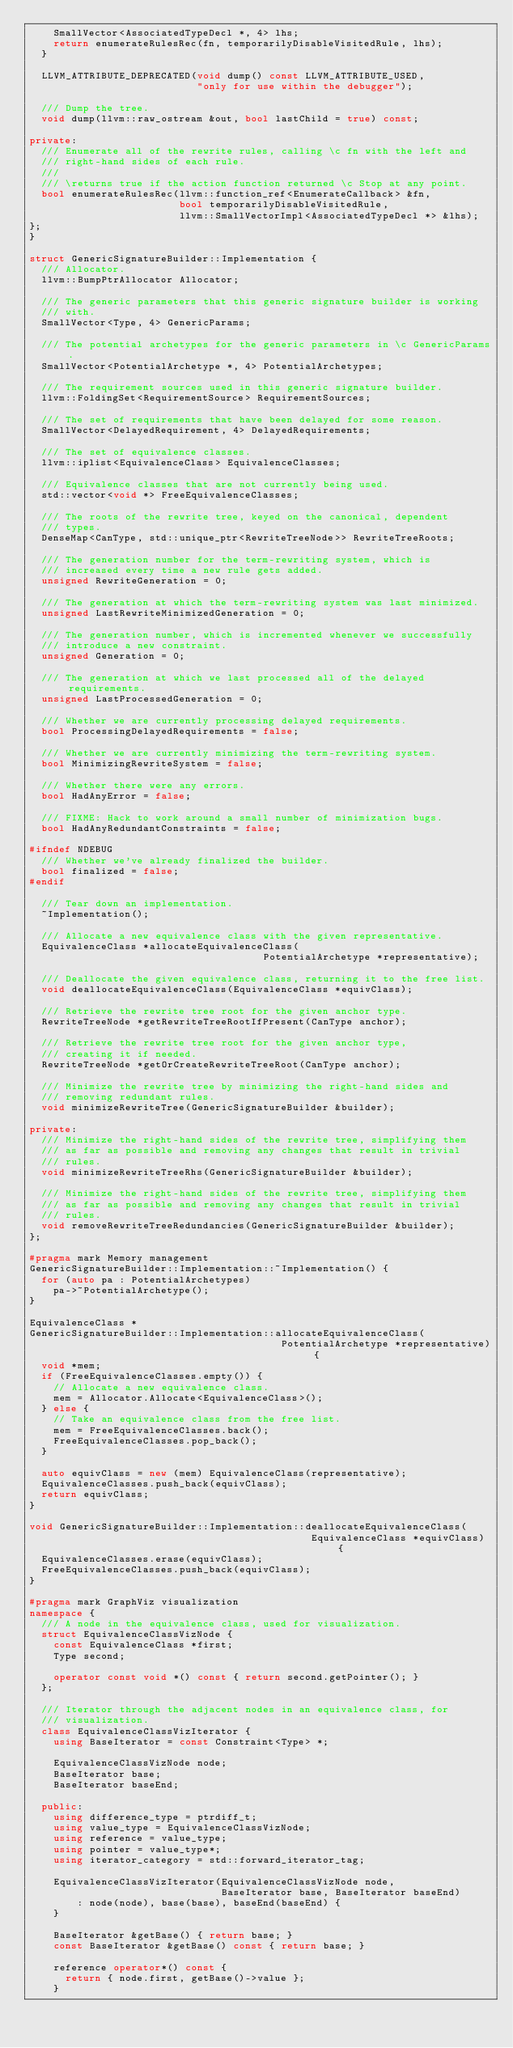<code> <loc_0><loc_0><loc_500><loc_500><_C++_>    SmallVector<AssociatedTypeDecl *, 4> lhs;
    return enumerateRulesRec(fn, temporarilyDisableVisitedRule, lhs);
  }

  LLVM_ATTRIBUTE_DEPRECATED(void dump() const LLVM_ATTRIBUTE_USED,
                            "only for use within the debugger");

  /// Dump the tree.
  void dump(llvm::raw_ostream &out, bool lastChild = true) const;

private:
  /// Enumerate all of the rewrite rules, calling \c fn with the left and
  /// right-hand sides of each rule.
  ///
  /// \returns true if the action function returned \c Stop at any point.
  bool enumerateRulesRec(llvm::function_ref<EnumerateCallback> &fn,
                         bool temporarilyDisableVisitedRule,
                         llvm::SmallVectorImpl<AssociatedTypeDecl *> &lhs);
};
}

struct GenericSignatureBuilder::Implementation {
  /// Allocator.
  llvm::BumpPtrAllocator Allocator;

  /// The generic parameters that this generic signature builder is working
  /// with.
  SmallVector<Type, 4> GenericParams;

  /// The potential archetypes for the generic parameters in \c GenericParams.
  SmallVector<PotentialArchetype *, 4> PotentialArchetypes;

  /// The requirement sources used in this generic signature builder.
  llvm::FoldingSet<RequirementSource> RequirementSources;

  /// The set of requirements that have been delayed for some reason.
  SmallVector<DelayedRequirement, 4> DelayedRequirements;

  /// The set of equivalence classes.
  llvm::iplist<EquivalenceClass> EquivalenceClasses;

  /// Equivalence classes that are not currently being used.
  std::vector<void *> FreeEquivalenceClasses;

  /// The roots of the rewrite tree, keyed on the canonical, dependent
  /// types.
  DenseMap<CanType, std::unique_ptr<RewriteTreeNode>> RewriteTreeRoots;

  /// The generation number for the term-rewriting system, which is
  /// increased every time a new rule gets added.
  unsigned RewriteGeneration = 0;

  /// The generation at which the term-rewriting system was last minimized.
  unsigned LastRewriteMinimizedGeneration = 0;

  /// The generation number, which is incremented whenever we successfully
  /// introduce a new constraint.
  unsigned Generation = 0;

  /// The generation at which we last processed all of the delayed requirements.
  unsigned LastProcessedGeneration = 0;

  /// Whether we are currently processing delayed requirements.
  bool ProcessingDelayedRequirements = false;

  /// Whether we are currently minimizing the term-rewriting system.
  bool MinimizingRewriteSystem = false;

  /// Whether there were any errors.
  bool HadAnyError = false;

  /// FIXME: Hack to work around a small number of minimization bugs.
  bool HadAnyRedundantConstraints = false;

#ifndef NDEBUG
  /// Whether we've already finalized the builder.
  bool finalized = false;
#endif

  /// Tear down an implementation.
  ~Implementation();

  /// Allocate a new equivalence class with the given representative.
  EquivalenceClass *allocateEquivalenceClass(
                                       PotentialArchetype *representative);

  /// Deallocate the given equivalence class, returning it to the free list.
  void deallocateEquivalenceClass(EquivalenceClass *equivClass);

  /// Retrieve the rewrite tree root for the given anchor type.
  RewriteTreeNode *getRewriteTreeRootIfPresent(CanType anchor);

  /// Retrieve the rewrite tree root for the given anchor type,
  /// creating it if needed.
  RewriteTreeNode *getOrCreateRewriteTreeRoot(CanType anchor);

  /// Minimize the rewrite tree by minimizing the right-hand sides and
  /// removing redundant rules.
  void minimizeRewriteTree(GenericSignatureBuilder &builder);

private:
  /// Minimize the right-hand sides of the rewrite tree, simplifying them
  /// as far as possible and removing any changes that result in trivial
  /// rules.
  void minimizeRewriteTreeRhs(GenericSignatureBuilder &builder);

  /// Minimize the right-hand sides of the rewrite tree, simplifying them
  /// as far as possible and removing any changes that result in trivial
  /// rules.
  void removeRewriteTreeRedundancies(GenericSignatureBuilder &builder);
};

#pragma mark Memory management
GenericSignatureBuilder::Implementation::~Implementation() {
  for (auto pa : PotentialArchetypes)
    pa->~PotentialArchetype();
}

EquivalenceClass *
GenericSignatureBuilder::Implementation::allocateEquivalenceClass(
                                          PotentialArchetype *representative) {
  void *mem;
  if (FreeEquivalenceClasses.empty()) {
    // Allocate a new equivalence class.
    mem = Allocator.Allocate<EquivalenceClass>();
  } else {
    // Take an equivalence class from the free list.
    mem = FreeEquivalenceClasses.back();
    FreeEquivalenceClasses.pop_back();
  }

  auto equivClass = new (mem) EquivalenceClass(representative);
  EquivalenceClasses.push_back(equivClass);
  return equivClass;
}

void GenericSignatureBuilder::Implementation::deallocateEquivalenceClass(
                                               EquivalenceClass *equivClass) {
  EquivalenceClasses.erase(equivClass);
  FreeEquivalenceClasses.push_back(equivClass);
}

#pragma mark GraphViz visualization
namespace {
  /// A node in the equivalence class, used for visualization.
  struct EquivalenceClassVizNode {
    const EquivalenceClass *first;
    Type second;

    operator const void *() const { return second.getPointer(); }
  };

  /// Iterator through the adjacent nodes in an equivalence class, for
  /// visualization.
  class EquivalenceClassVizIterator {
    using BaseIterator = const Constraint<Type> *;

    EquivalenceClassVizNode node;
    BaseIterator base;
    BaseIterator baseEnd;

  public:
    using difference_type = ptrdiff_t;
    using value_type = EquivalenceClassVizNode;
    using reference = value_type;
    using pointer = value_type*;
    using iterator_category = std::forward_iterator_tag;

    EquivalenceClassVizIterator(EquivalenceClassVizNode node,
                                BaseIterator base, BaseIterator baseEnd)
        : node(node), base(base), baseEnd(baseEnd) {
    }

    BaseIterator &getBase() { return base; }
    const BaseIterator &getBase() const { return base; }

    reference operator*() const {
      return { node.first, getBase()->value };
    }
</code> 